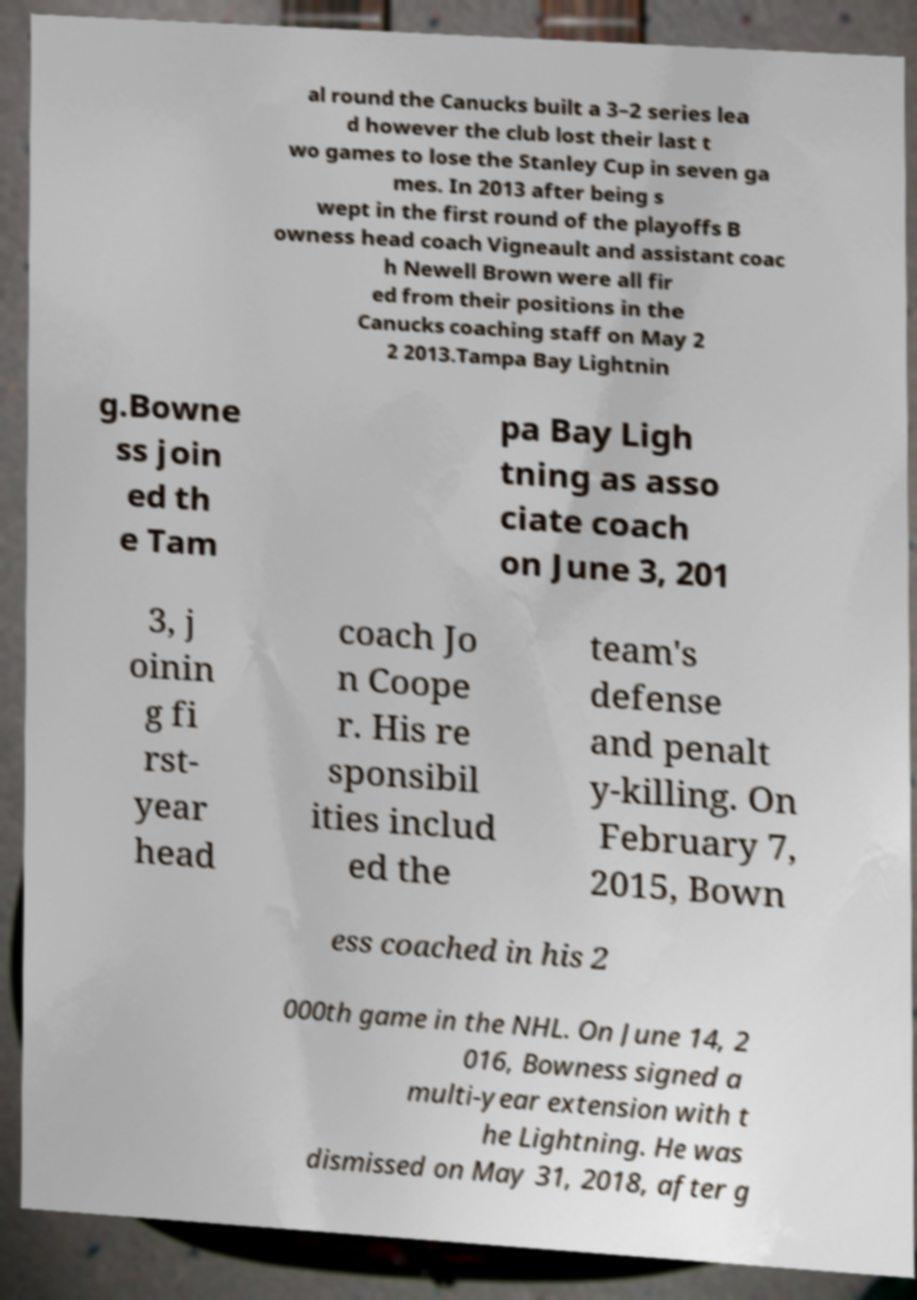For documentation purposes, I need the text within this image transcribed. Could you provide that? al round the Canucks built a 3–2 series lea d however the club lost their last t wo games to lose the Stanley Cup in seven ga mes. In 2013 after being s wept in the first round of the playoffs B owness head coach Vigneault and assistant coac h Newell Brown were all fir ed from their positions in the Canucks coaching staff on May 2 2 2013.Tampa Bay Lightnin g.Bowne ss join ed th e Tam pa Bay Ligh tning as asso ciate coach on June 3, 201 3, j oinin g fi rst- year head coach Jo n Coope r. His re sponsibil ities includ ed the team's defense and penalt y-killing. On February 7, 2015, Bown ess coached in his 2 000th game in the NHL. On June 14, 2 016, Bowness signed a multi-year extension with t he Lightning. He was dismissed on May 31, 2018, after g 